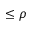Convert formula to latex. <formula><loc_0><loc_0><loc_500><loc_500>\leq \rho</formula> 